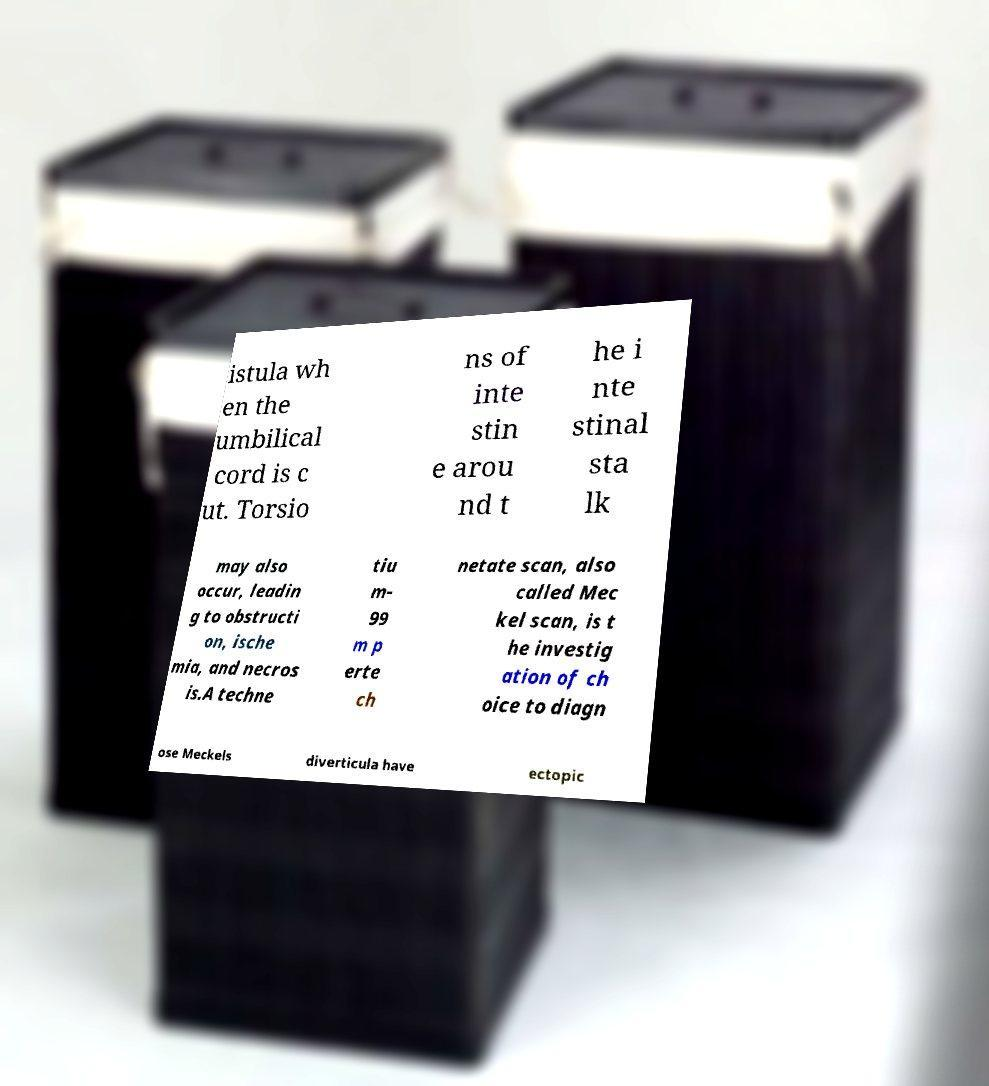Could you extract and type out the text from this image? istula wh en the umbilical cord is c ut. Torsio ns of inte stin e arou nd t he i nte stinal sta lk may also occur, leadin g to obstructi on, ische mia, and necros is.A techne tiu m- 99 m p erte ch netate scan, also called Mec kel scan, is t he investig ation of ch oice to diagn ose Meckels diverticula have ectopic 